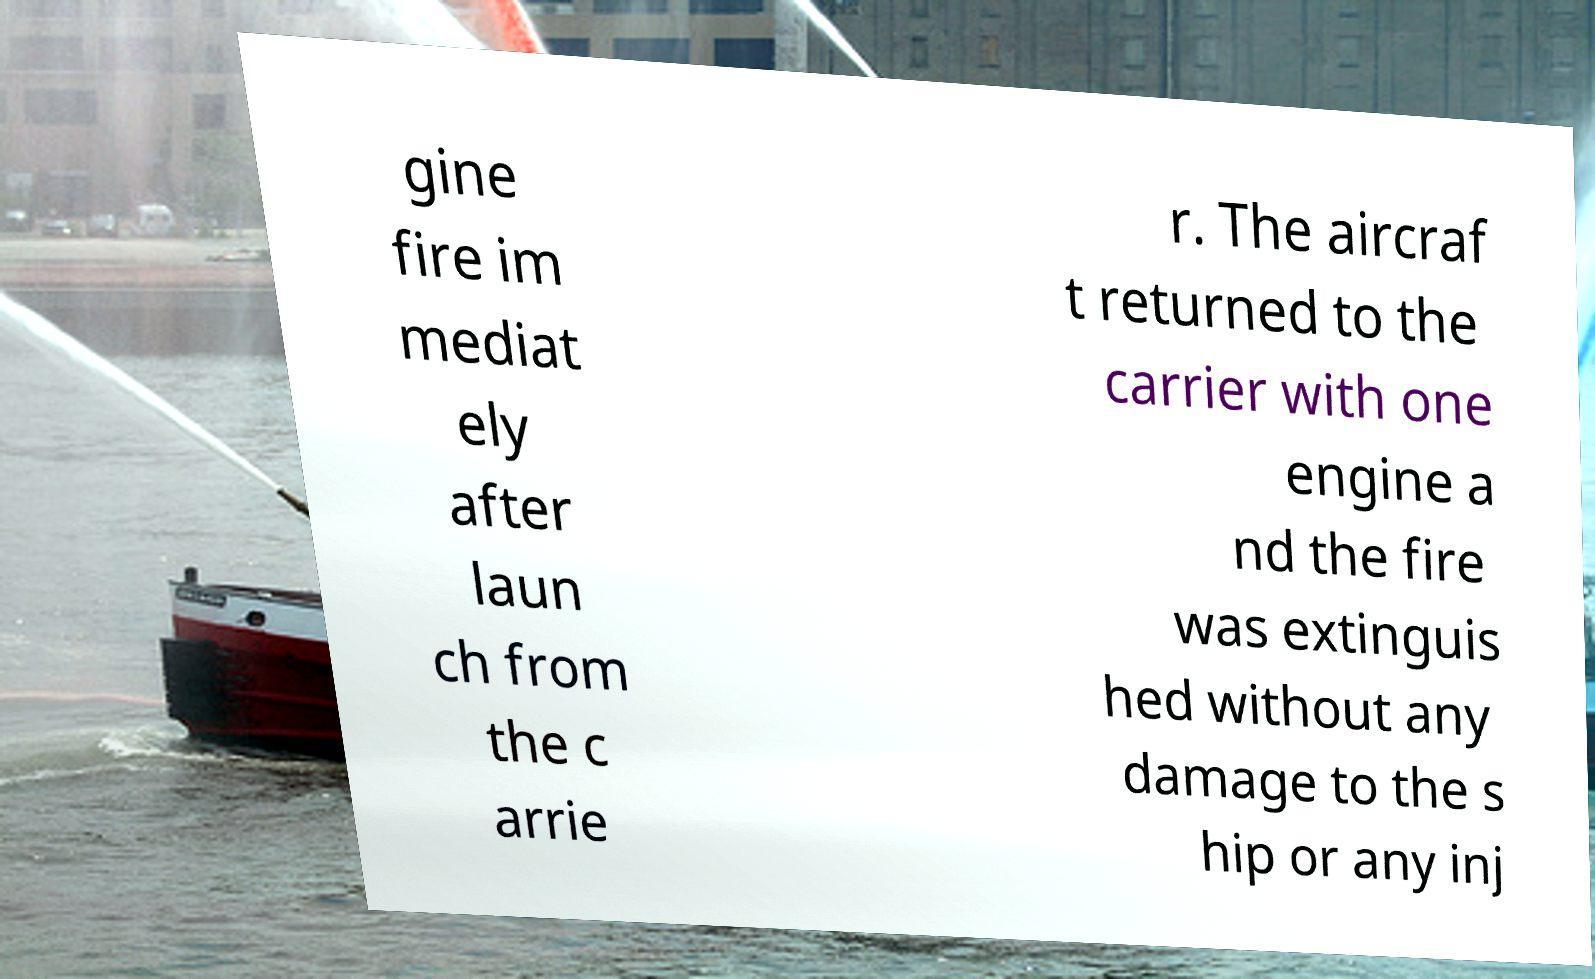Please identify and transcribe the text found in this image. gine fire im mediat ely after laun ch from the c arrie r. The aircraf t returned to the carrier with one engine a nd the fire was extinguis hed without any damage to the s hip or any inj 